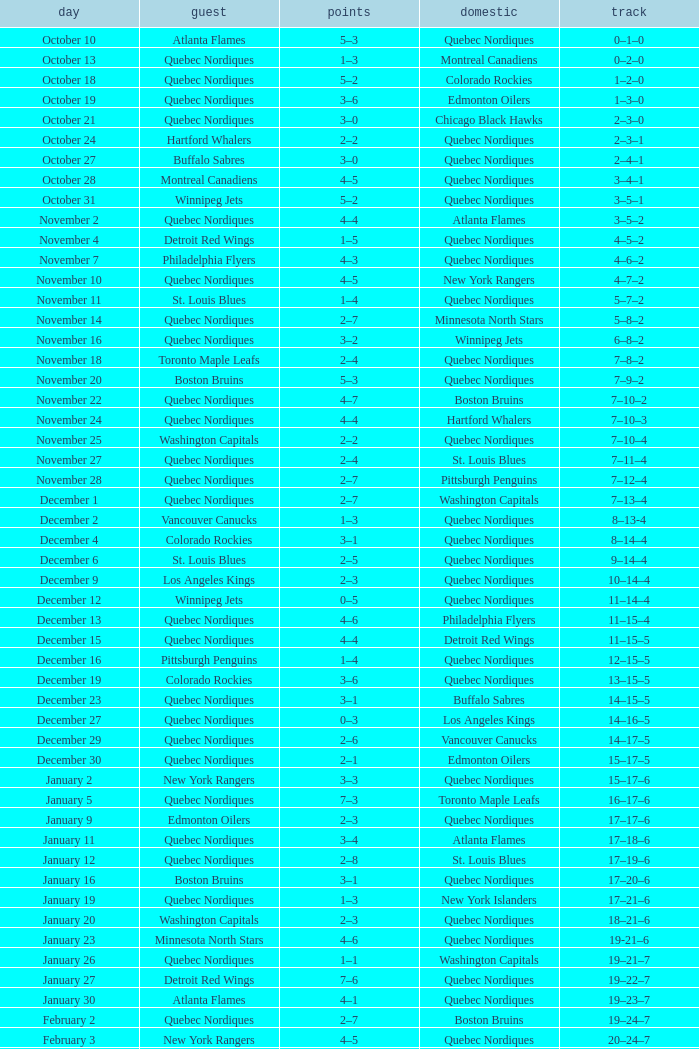Which Record has a Score of 2–4, and a Home of quebec nordiques? 7–8–2. 